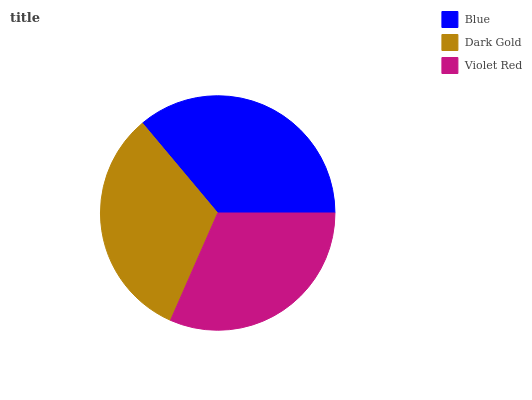Is Violet Red the minimum?
Answer yes or no. Yes. Is Blue the maximum?
Answer yes or no. Yes. Is Dark Gold the minimum?
Answer yes or no. No. Is Dark Gold the maximum?
Answer yes or no. No. Is Blue greater than Dark Gold?
Answer yes or no. Yes. Is Dark Gold less than Blue?
Answer yes or no. Yes. Is Dark Gold greater than Blue?
Answer yes or no. No. Is Blue less than Dark Gold?
Answer yes or no. No. Is Dark Gold the high median?
Answer yes or no. Yes. Is Dark Gold the low median?
Answer yes or no. Yes. Is Violet Red the high median?
Answer yes or no. No. Is Violet Red the low median?
Answer yes or no. No. 